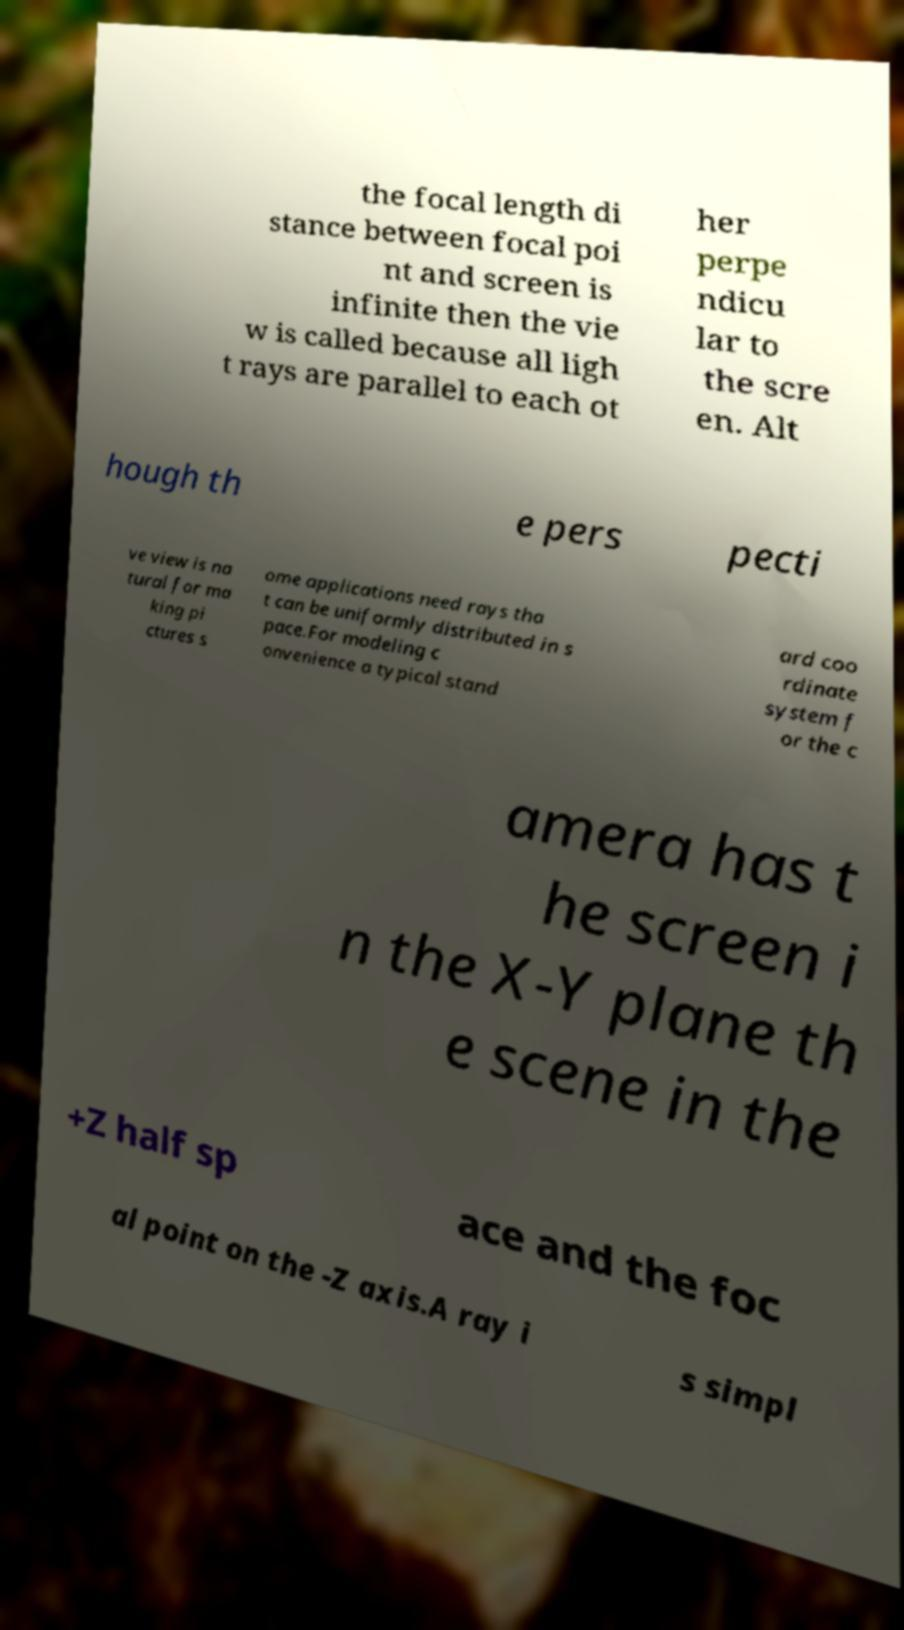For documentation purposes, I need the text within this image transcribed. Could you provide that? the focal length di stance between focal poi nt and screen is infinite then the vie w is called because all ligh t rays are parallel to each ot her perpe ndicu lar to the scre en. Alt hough th e pers pecti ve view is na tural for ma king pi ctures s ome applications need rays tha t can be uniformly distributed in s pace.For modeling c onvenience a typical stand ard coo rdinate system f or the c amera has t he screen i n the X-Y plane th e scene in the +Z half sp ace and the foc al point on the -Z axis.A ray i s simpl 